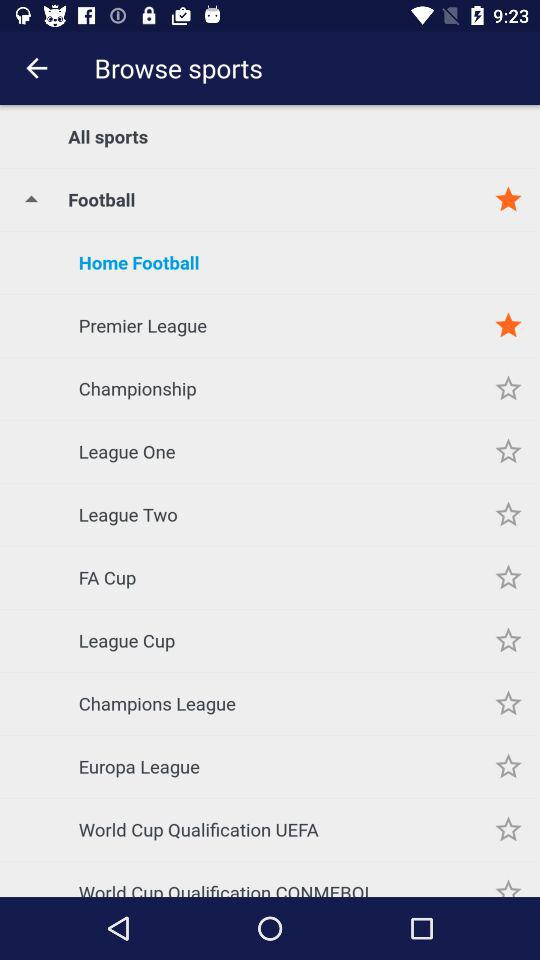What kind of football match is selected? The selected kind of football match is "Home Football". 